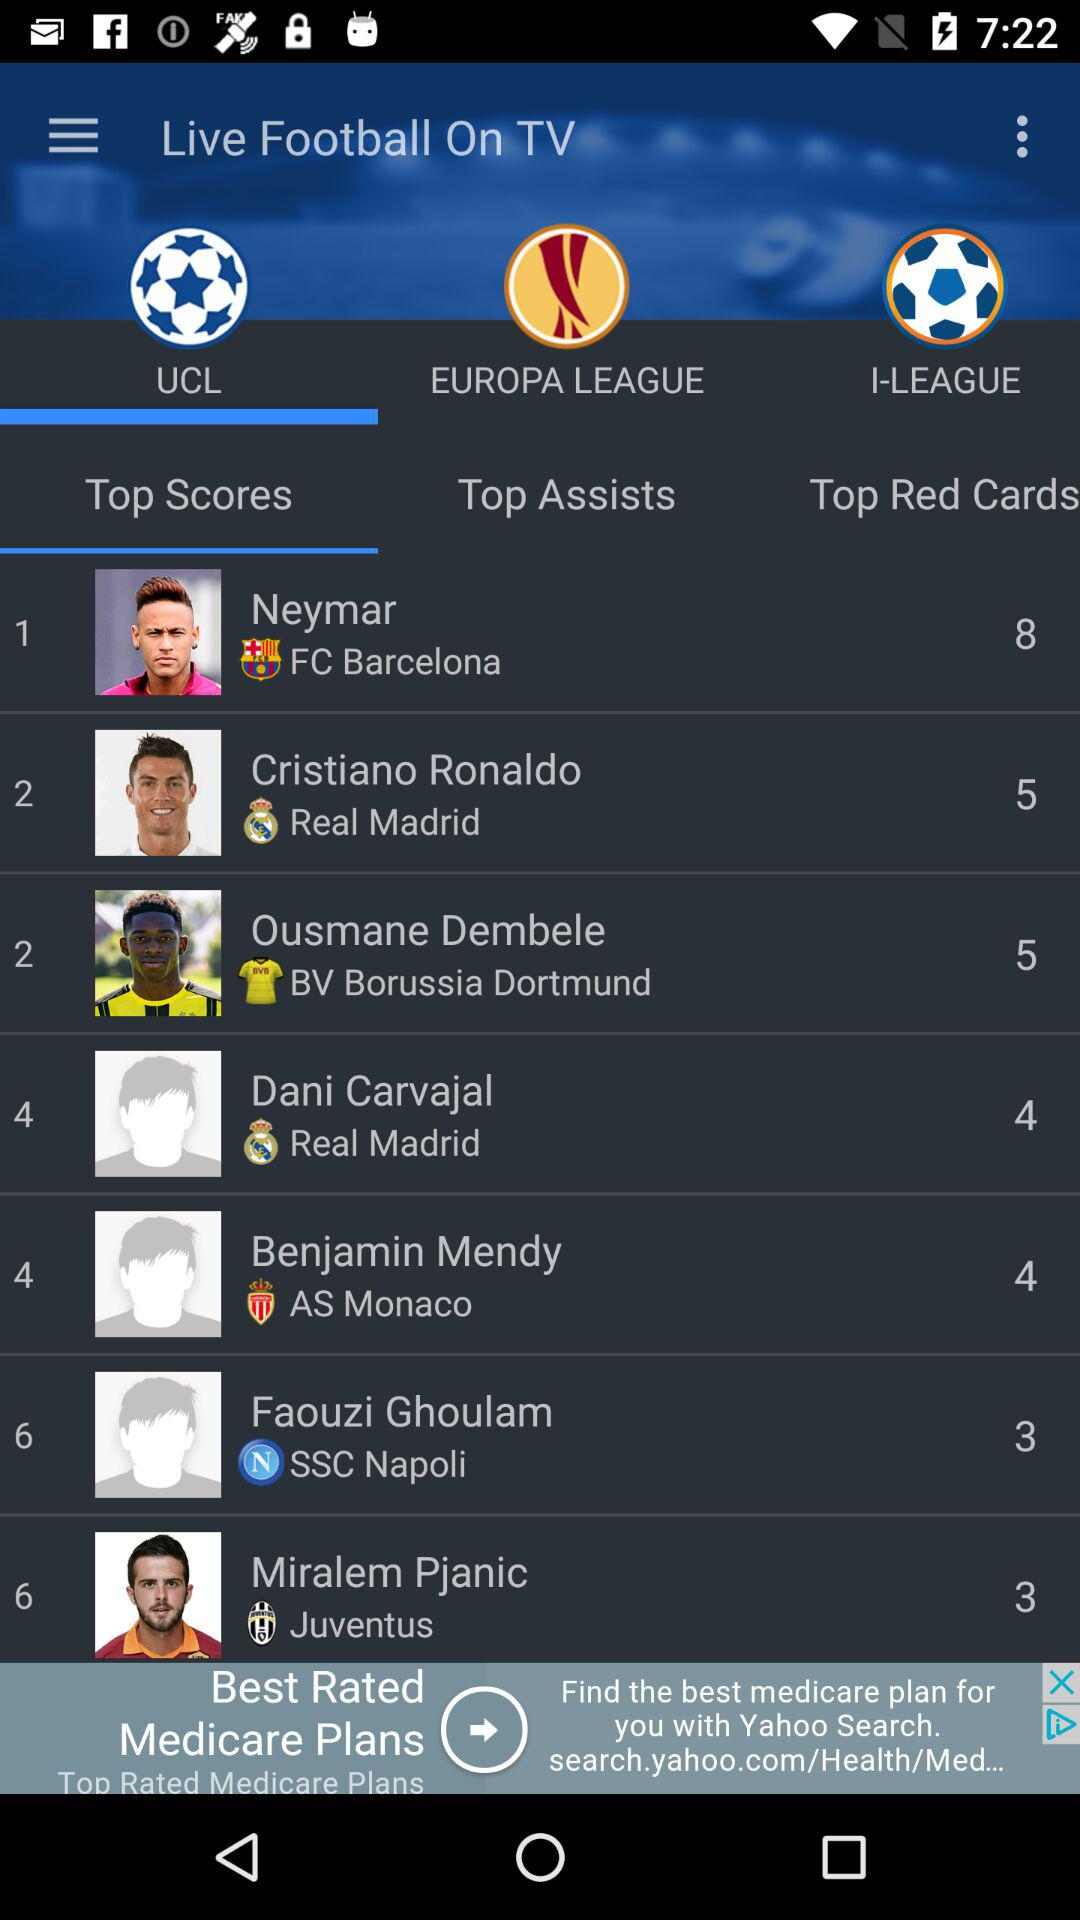Which club does Dani Carvajal represent? Dani Carvajal represents the club "Real Madrid". 